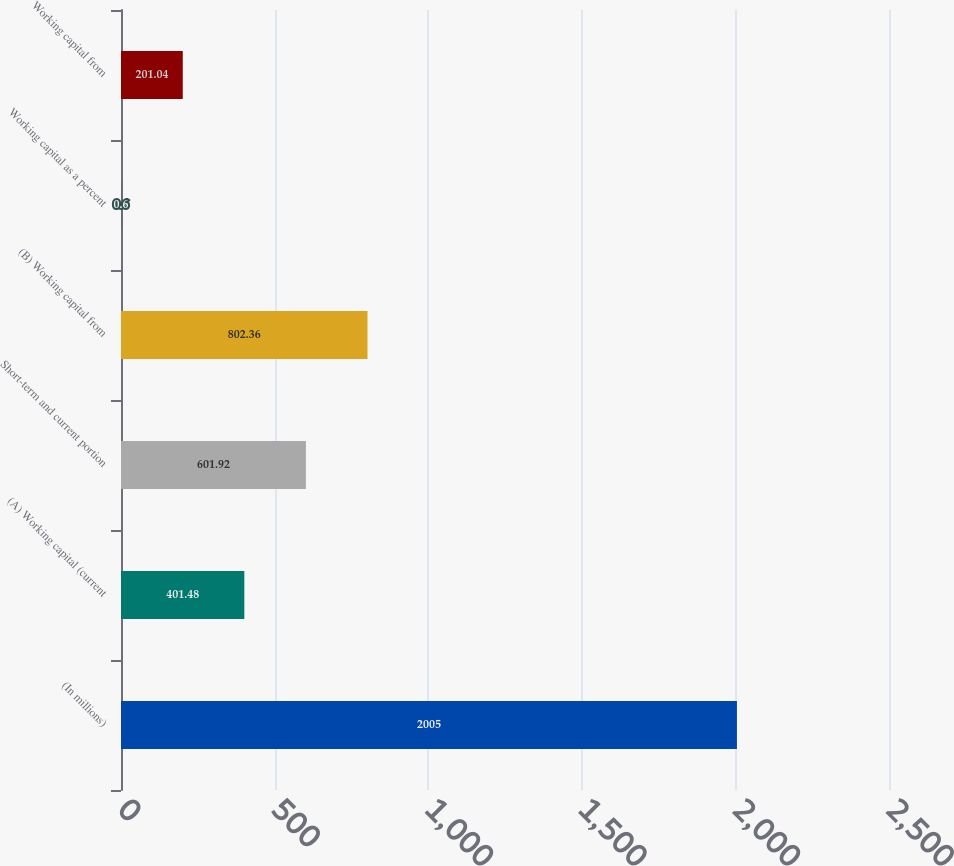Convert chart to OTSL. <chart><loc_0><loc_0><loc_500><loc_500><bar_chart><fcel>(In millions)<fcel>(A) Working capital (current<fcel>Short-term and current portion<fcel>(B) Working capital from<fcel>Working capital as a percent<fcel>Working capital from<nl><fcel>2005<fcel>401.48<fcel>601.92<fcel>802.36<fcel>0.6<fcel>201.04<nl></chart> 